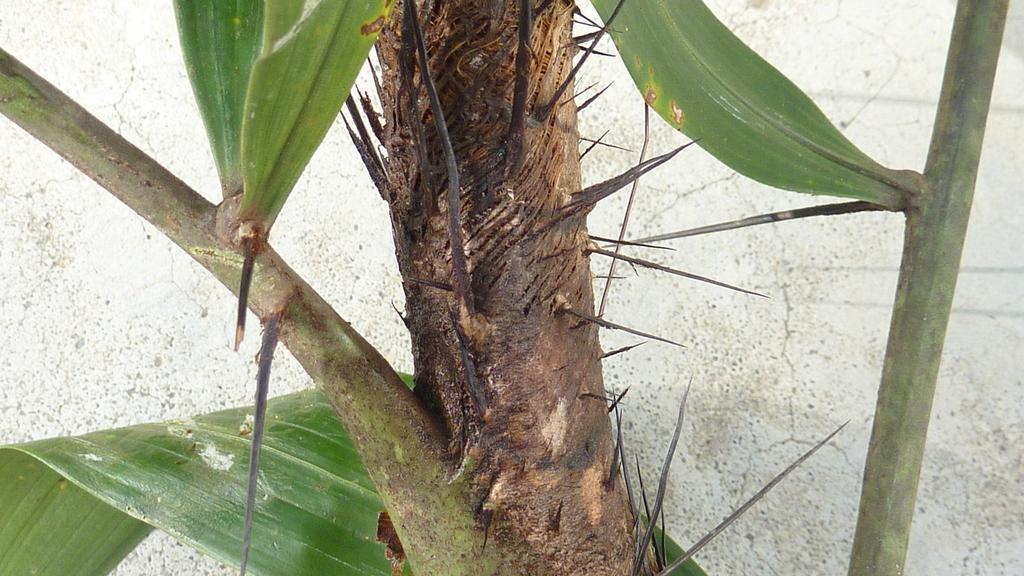Please provide a concise description of this image. In this image I can see a plant with some sharp pain like edges and some leaves. 